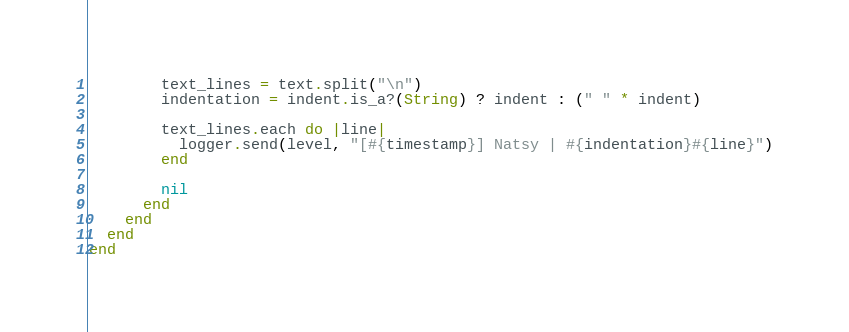<code> <loc_0><loc_0><loc_500><loc_500><_Ruby_>        text_lines = text.split("\n")
        indentation = indent.is_a?(String) ? indent : (" " * indent)

        text_lines.each do |line|
          logger.send(level, "[#{timestamp}] Natsy | #{indentation}#{line}")
        end

        nil
      end
    end
  end
end
</code> 